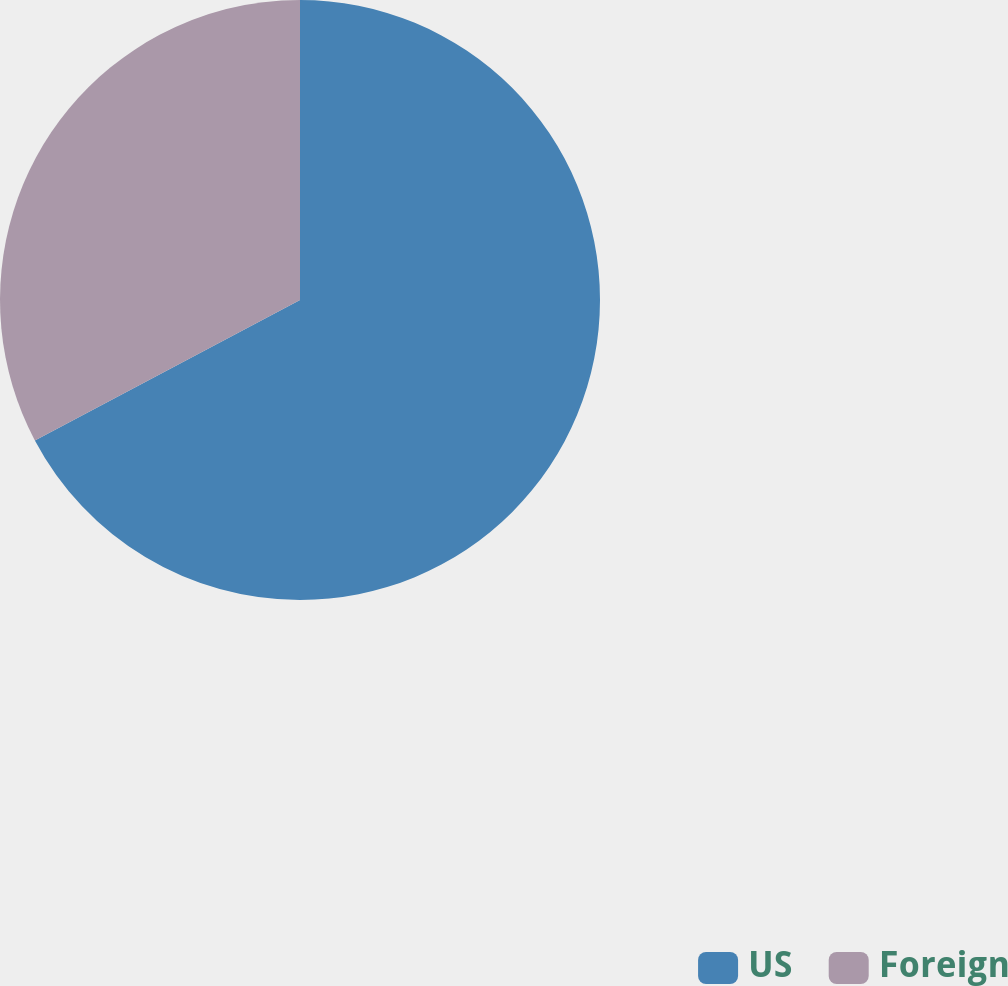Convert chart to OTSL. <chart><loc_0><loc_0><loc_500><loc_500><pie_chart><fcel>US<fcel>Foreign<nl><fcel>67.25%<fcel>32.75%<nl></chart> 